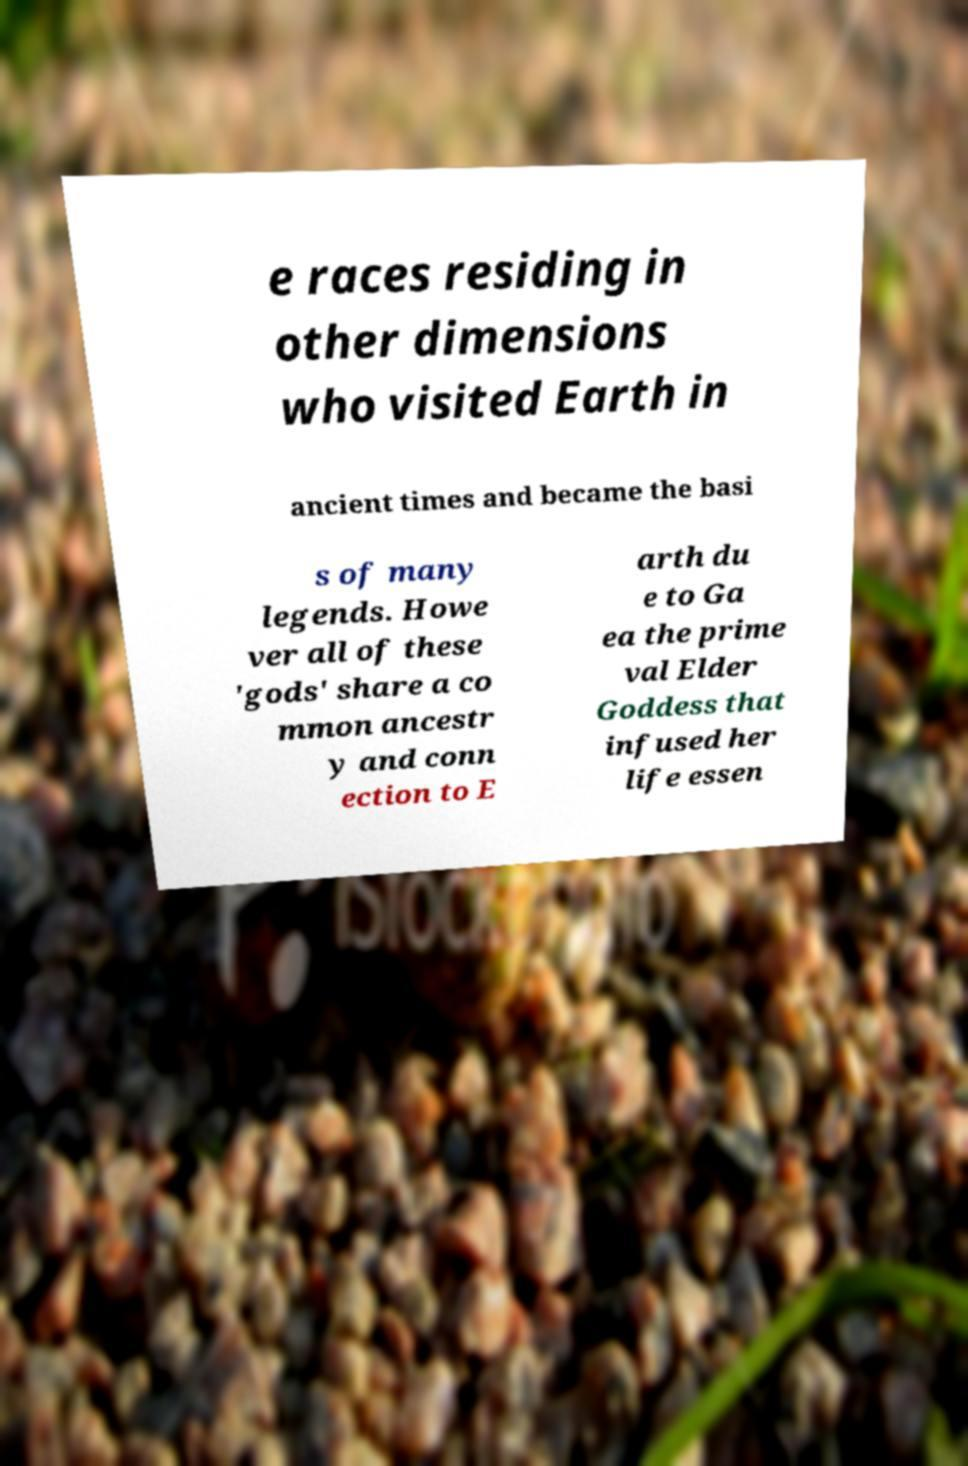I need the written content from this picture converted into text. Can you do that? e races residing in other dimensions who visited Earth in ancient times and became the basi s of many legends. Howe ver all of these 'gods' share a co mmon ancestr y and conn ection to E arth du e to Ga ea the prime val Elder Goddess that infused her life essen 